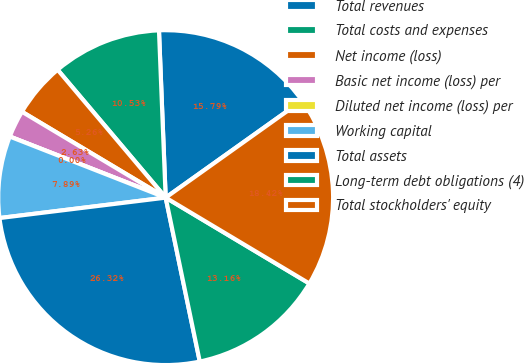Convert chart. <chart><loc_0><loc_0><loc_500><loc_500><pie_chart><fcel>Total revenues<fcel>Total costs and expenses<fcel>Net income (loss)<fcel>Basic net income (loss) per<fcel>Diluted net income (loss) per<fcel>Working capital<fcel>Total assets<fcel>Long-term debt obligations (4)<fcel>Total stockholders' equity<nl><fcel>15.79%<fcel>10.53%<fcel>5.26%<fcel>2.63%<fcel>0.0%<fcel>7.89%<fcel>26.32%<fcel>13.16%<fcel>18.42%<nl></chart> 